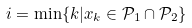<formula> <loc_0><loc_0><loc_500><loc_500>i = \min \{ k | x _ { k } \in \mathcal { P } _ { 1 } \cap \mathcal { P } _ { 2 } \}</formula> 